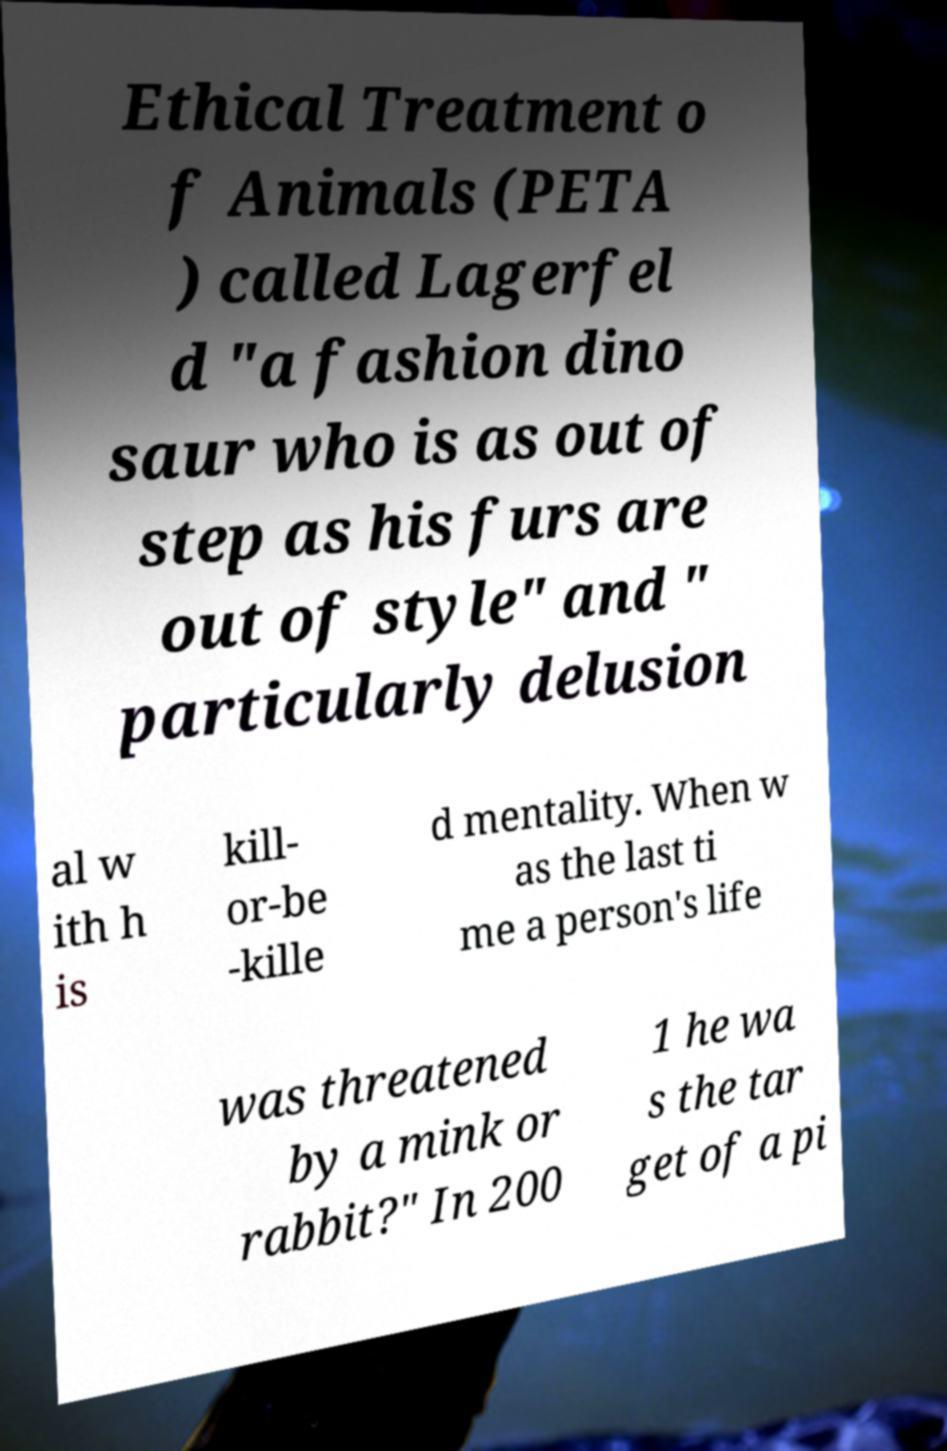Could you extract and type out the text from this image? Ethical Treatment o f Animals (PETA ) called Lagerfel d "a fashion dino saur who is as out of step as his furs are out of style" and " particularly delusion al w ith h is kill- or-be -kille d mentality. When w as the last ti me a person's life was threatened by a mink or rabbit?" In 200 1 he wa s the tar get of a pi 